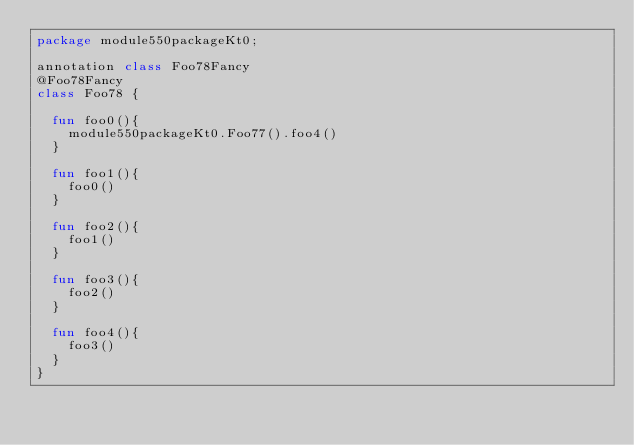<code> <loc_0><loc_0><loc_500><loc_500><_Kotlin_>package module550packageKt0;

annotation class Foo78Fancy
@Foo78Fancy
class Foo78 {

  fun foo0(){
    module550packageKt0.Foo77().foo4()
  }

  fun foo1(){
    foo0()
  }

  fun foo2(){
    foo1()
  }

  fun foo3(){
    foo2()
  }

  fun foo4(){
    foo3()
  }
}</code> 